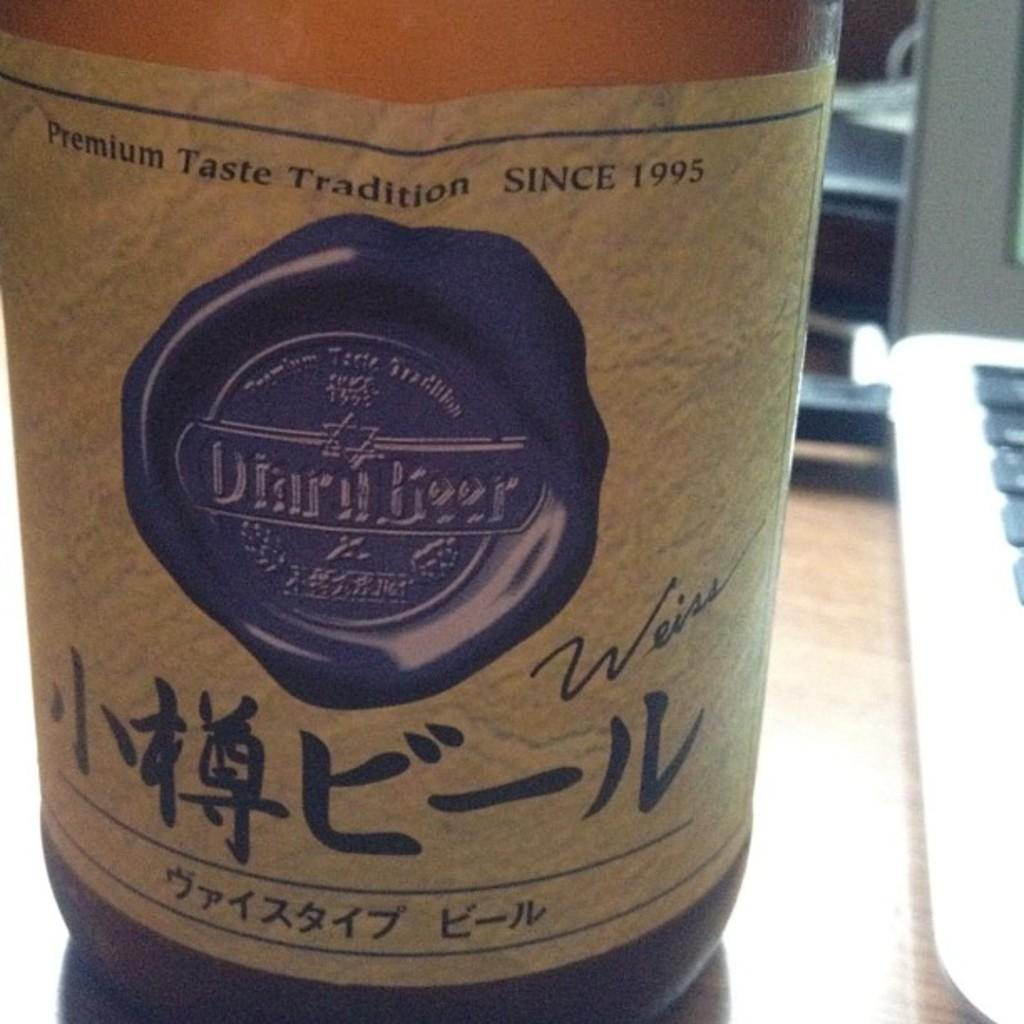<image>
Relay a brief, clear account of the picture shown. a bottle that has a beige label on it that says 'premium taste tradition since 1995' 